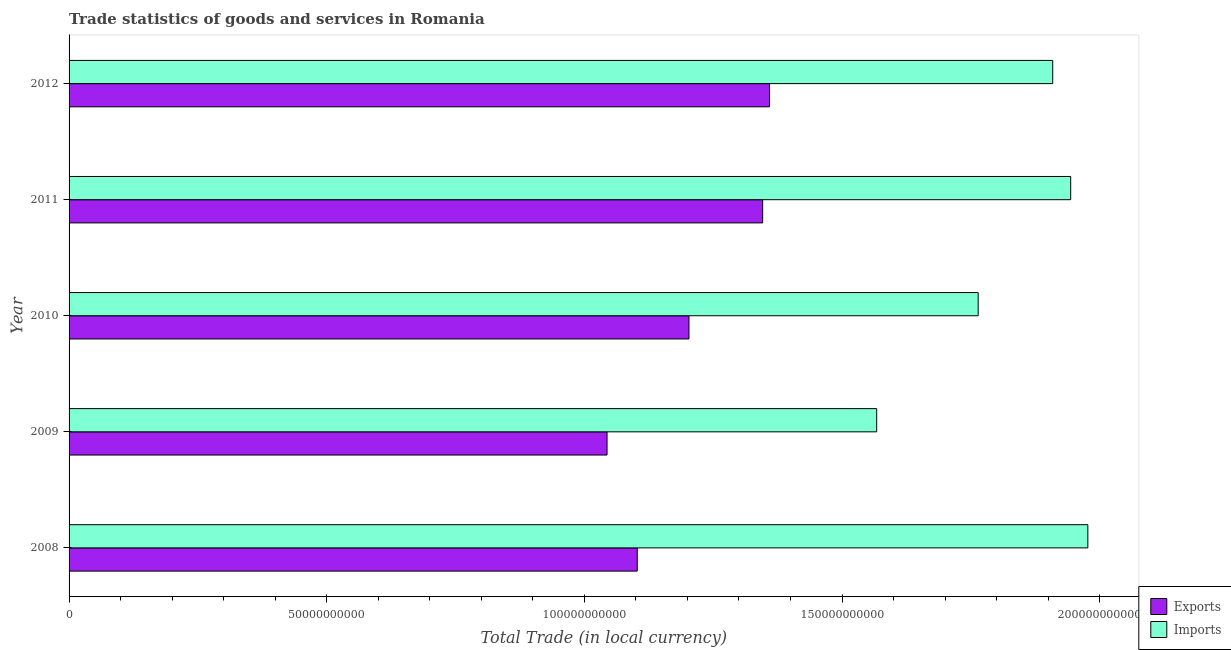How many groups of bars are there?
Make the answer very short. 5. Are the number of bars on each tick of the Y-axis equal?
Your answer should be very brief. Yes. How many bars are there on the 2nd tick from the top?
Provide a succinct answer. 2. How many bars are there on the 3rd tick from the bottom?
Give a very brief answer. 2. What is the label of the 3rd group of bars from the top?
Give a very brief answer. 2010. In how many cases, is the number of bars for a given year not equal to the number of legend labels?
Keep it short and to the point. 0. What is the imports of goods and services in 2011?
Ensure brevity in your answer.  1.94e+11. Across all years, what is the maximum export of goods and services?
Your response must be concise. 1.36e+11. Across all years, what is the minimum export of goods and services?
Keep it short and to the point. 1.04e+11. In which year was the export of goods and services maximum?
Keep it short and to the point. 2012. What is the total imports of goods and services in the graph?
Provide a succinct answer. 9.16e+11. What is the difference between the imports of goods and services in 2009 and that in 2012?
Provide a short and direct response. -3.42e+1. What is the difference between the export of goods and services in 2008 and the imports of goods and services in 2011?
Provide a succinct answer. -8.41e+1. What is the average imports of goods and services per year?
Your answer should be very brief. 1.83e+11. In the year 2009, what is the difference between the imports of goods and services and export of goods and services?
Ensure brevity in your answer.  5.23e+1. What is the ratio of the export of goods and services in 2011 to that in 2012?
Offer a terse response. 0.99. Is the imports of goods and services in 2010 less than that in 2012?
Keep it short and to the point. Yes. Is the difference between the export of goods and services in 2011 and 2012 greater than the difference between the imports of goods and services in 2011 and 2012?
Make the answer very short. No. What is the difference between the highest and the second highest imports of goods and services?
Give a very brief answer. 3.33e+09. What is the difference between the highest and the lowest imports of goods and services?
Ensure brevity in your answer.  4.10e+1. What does the 1st bar from the top in 2010 represents?
Ensure brevity in your answer.  Imports. What does the 2nd bar from the bottom in 2008 represents?
Offer a terse response. Imports. Are all the bars in the graph horizontal?
Provide a succinct answer. Yes. How many years are there in the graph?
Offer a very short reply. 5. Are the values on the major ticks of X-axis written in scientific E-notation?
Provide a succinct answer. No. Does the graph contain any zero values?
Provide a short and direct response. No. What is the title of the graph?
Offer a very short reply. Trade statistics of goods and services in Romania. What is the label or title of the X-axis?
Offer a terse response. Total Trade (in local currency). What is the Total Trade (in local currency) in Exports in 2008?
Your answer should be very brief. 1.10e+11. What is the Total Trade (in local currency) of Imports in 2008?
Provide a succinct answer. 1.98e+11. What is the Total Trade (in local currency) of Exports in 2009?
Your answer should be compact. 1.04e+11. What is the Total Trade (in local currency) in Imports in 2009?
Keep it short and to the point. 1.57e+11. What is the Total Trade (in local currency) in Exports in 2010?
Provide a succinct answer. 1.20e+11. What is the Total Trade (in local currency) in Imports in 2010?
Offer a terse response. 1.76e+11. What is the Total Trade (in local currency) in Exports in 2011?
Offer a terse response. 1.35e+11. What is the Total Trade (in local currency) in Imports in 2011?
Give a very brief answer. 1.94e+11. What is the Total Trade (in local currency) in Exports in 2012?
Keep it short and to the point. 1.36e+11. What is the Total Trade (in local currency) in Imports in 2012?
Keep it short and to the point. 1.91e+11. Across all years, what is the maximum Total Trade (in local currency) in Exports?
Your response must be concise. 1.36e+11. Across all years, what is the maximum Total Trade (in local currency) in Imports?
Make the answer very short. 1.98e+11. Across all years, what is the minimum Total Trade (in local currency) of Exports?
Provide a succinct answer. 1.04e+11. Across all years, what is the minimum Total Trade (in local currency) of Imports?
Make the answer very short. 1.57e+11. What is the total Total Trade (in local currency) of Exports in the graph?
Your response must be concise. 6.05e+11. What is the total Total Trade (in local currency) in Imports in the graph?
Give a very brief answer. 9.16e+11. What is the difference between the Total Trade (in local currency) of Exports in 2008 and that in 2009?
Ensure brevity in your answer.  5.86e+09. What is the difference between the Total Trade (in local currency) of Imports in 2008 and that in 2009?
Offer a very short reply. 4.10e+1. What is the difference between the Total Trade (in local currency) of Exports in 2008 and that in 2010?
Offer a terse response. -1.00e+1. What is the difference between the Total Trade (in local currency) of Imports in 2008 and that in 2010?
Offer a very short reply. 2.13e+1. What is the difference between the Total Trade (in local currency) of Exports in 2008 and that in 2011?
Make the answer very short. -2.43e+1. What is the difference between the Total Trade (in local currency) in Imports in 2008 and that in 2011?
Offer a very short reply. 3.33e+09. What is the difference between the Total Trade (in local currency) in Exports in 2008 and that in 2012?
Make the answer very short. -2.57e+1. What is the difference between the Total Trade (in local currency) of Imports in 2008 and that in 2012?
Offer a terse response. 6.82e+09. What is the difference between the Total Trade (in local currency) of Exports in 2009 and that in 2010?
Offer a terse response. -1.59e+1. What is the difference between the Total Trade (in local currency) in Imports in 2009 and that in 2010?
Give a very brief answer. -1.97e+1. What is the difference between the Total Trade (in local currency) in Exports in 2009 and that in 2011?
Offer a very short reply. -3.02e+1. What is the difference between the Total Trade (in local currency) in Imports in 2009 and that in 2011?
Give a very brief answer. -3.76e+1. What is the difference between the Total Trade (in local currency) of Exports in 2009 and that in 2012?
Ensure brevity in your answer.  -3.15e+1. What is the difference between the Total Trade (in local currency) in Imports in 2009 and that in 2012?
Offer a very short reply. -3.42e+1. What is the difference between the Total Trade (in local currency) of Exports in 2010 and that in 2011?
Your response must be concise. -1.43e+1. What is the difference between the Total Trade (in local currency) in Imports in 2010 and that in 2011?
Provide a succinct answer. -1.80e+1. What is the difference between the Total Trade (in local currency) in Exports in 2010 and that in 2012?
Offer a very short reply. -1.56e+1. What is the difference between the Total Trade (in local currency) in Imports in 2010 and that in 2012?
Give a very brief answer. -1.45e+1. What is the difference between the Total Trade (in local currency) in Exports in 2011 and that in 2012?
Give a very brief answer. -1.33e+09. What is the difference between the Total Trade (in local currency) of Imports in 2011 and that in 2012?
Your response must be concise. 3.49e+09. What is the difference between the Total Trade (in local currency) in Exports in 2008 and the Total Trade (in local currency) in Imports in 2009?
Make the answer very short. -4.65e+1. What is the difference between the Total Trade (in local currency) of Exports in 2008 and the Total Trade (in local currency) of Imports in 2010?
Provide a succinct answer. -6.62e+1. What is the difference between the Total Trade (in local currency) in Exports in 2008 and the Total Trade (in local currency) in Imports in 2011?
Keep it short and to the point. -8.41e+1. What is the difference between the Total Trade (in local currency) in Exports in 2008 and the Total Trade (in local currency) in Imports in 2012?
Provide a short and direct response. -8.06e+1. What is the difference between the Total Trade (in local currency) in Exports in 2009 and the Total Trade (in local currency) in Imports in 2010?
Keep it short and to the point. -7.20e+1. What is the difference between the Total Trade (in local currency) in Exports in 2009 and the Total Trade (in local currency) in Imports in 2011?
Offer a very short reply. -9.00e+1. What is the difference between the Total Trade (in local currency) of Exports in 2009 and the Total Trade (in local currency) of Imports in 2012?
Ensure brevity in your answer.  -8.65e+1. What is the difference between the Total Trade (in local currency) of Exports in 2010 and the Total Trade (in local currency) of Imports in 2011?
Give a very brief answer. -7.41e+1. What is the difference between the Total Trade (in local currency) in Exports in 2010 and the Total Trade (in local currency) in Imports in 2012?
Give a very brief answer. -7.06e+1. What is the difference between the Total Trade (in local currency) in Exports in 2011 and the Total Trade (in local currency) in Imports in 2012?
Give a very brief answer. -5.63e+1. What is the average Total Trade (in local currency) of Exports per year?
Keep it short and to the point. 1.21e+11. What is the average Total Trade (in local currency) in Imports per year?
Offer a terse response. 1.83e+11. In the year 2008, what is the difference between the Total Trade (in local currency) of Exports and Total Trade (in local currency) of Imports?
Your answer should be very brief. -8.74e+1. In the year 2009, what is the difference between the Total Trade (in local currency) of Exports and Total Trade (in local currency) of Imports?
Your answer should be very brief. -5.23e+1. In the year 2010, what is the difference between the Total Trade (in local currency) in Exports and Total Trade (in local currency) in Imports?
Your answer should be compact. -5.61e+1. In the year 2011, what is the difference between the Total Trade (in local currency) in Exports and Total Trade (in local currency) in Imports?
Offer a very short reply. -5.98e+1. In the year 2012, what is the difference between the Total Trade (in local currency) in Exports and Total Trade (in local currency) in Imports?
Provide a succinct answer. -5.50e+1. What is the ratio of the Total Trade (in local currency) of Exports in 2008 to that in 2009?
Provide a short and direct response. 1.06. What is the ratio of the Total Trade (in local currency) of Imports in 2008 to that in 2009?
Offer a terse response. 1.26. What is the ratio of the Total Trade (in local currency) in Exports in 2008 to that in 2010?
Provide a succinct answer. 0.92. What is the ratio of the Total Trade (in local currency) in Imports in 2008 to that in 2010?
Keep it short and to the point. 1.12. What is the ratio of the Total Trade (in local currency) of Exports in 2008 to that in 2011?
Make the answer very short. 0.82. What is the ratio of the Total Trade (in local currency) of Imports in 2008 to that in 2011?
Provide a succinct answer. 1.02. What is the ratio of the Total Trade (in local currency) of Exports in 2008 to that in 2012?
Your answer should be very brief. 0.81. What is the ratio of the Total Trade (in local currency) in Imports in 2008 to that in 2012?
Your answer should be compact. 1.04. What is the ratio of the Total Trade (in local currency) in Exports in 2009 to that in 2010?
Give a very brief answer. 0.87. What is the ratio of the Total Trade (in local currency) of Imports in 2009 to that in 2010?
Offer a very short reply. 0.89. What is the ratio of the Total Trade (in local currency) in Exports in 2009 to that in 2011?
Give a very brief answer. 0.78. What is the ratio of the Total Trade (in local currency) in Imports in 2009 to that in 2011?
Your response must be concise. 0.81. What is the ratio of the Total Trade (in local currency) in Exports in 2009 to that in 2012?
Your answer should be very brief. 0.77. What is the ratio of the Total Trade (in local currency) of Imports in 2009 to that in 2012?
Your answer should be compact. 0.82. What is the ratio of the Total Trade (in local currency) in Exports in 2010 to that in 2011?
Your answer should be compact. 0.89. What is the ratio of the Total Trade (in local currency) of Imports in 2010 to that in 2011?
Your response must be concise. 0.91. What is the ratio of the Total Trade (in local currency) of Exports in 2010 to that in 2012?
Ensure brevity in your answer.  0.89. What is the ratio of the Total Trade (in local currency) of Imports in 2010 to that in 2012?
Offer a terse response. 0.92. What is the ratio of the Total Trade (in local currency) in Exports in 2011 to that in 2012?
Offer a very short reply. 0.99. What is the ratio of the Total Trade (in local currency) of Imports in 2011 to that in 2012?
Your response must be concise. 1.02. What is the difference between the highest and the second highest Total Trade (in local currency) of Exports?
Provide a short and direct response. 1.33e+09. What is the difference between the highest and the second highest Total Trade (in local currency) of Imports?
Provide a short and direct response. 3.33e+09. What is the difference between the highest and the lowest Total Trade (in local currency) of Exports?
Give a very brief answer. 3.15e+1. What is the difference between the highest and the lowest Total Trade (in local currency) in Imports?
Provide a short and direct response. 4.10e+1. 